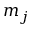<formula> <loc_0><loc_0><loc_500><loc_500>m _ { j }</formula> 